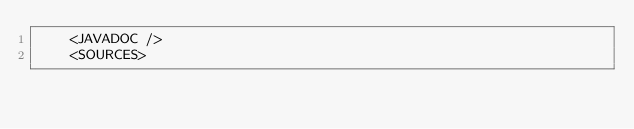<code> <loc_0><loc_0><loc_500><loc_500><_XML_>    <JAVADOC />
    <SOURCES></code> 